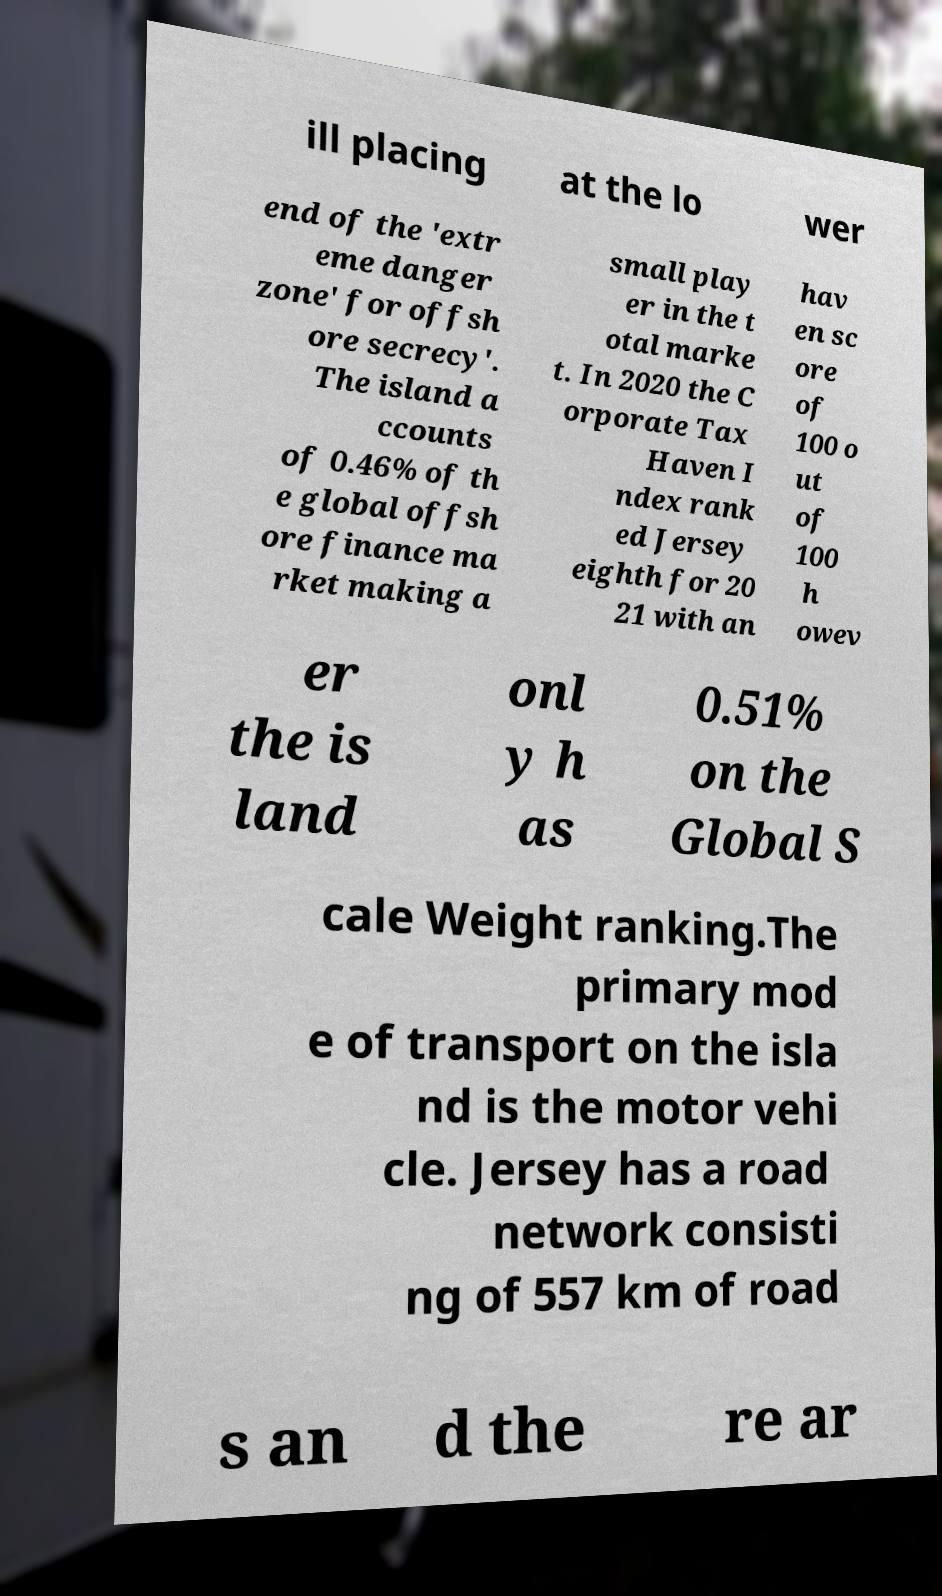Please read and relay the text visible in this image. What does it say? ill placing at the lo wer end of the 'extr eme danger zone' for offsh ore secrecy'. The island a ccounts of 0.46% of th e global offsh ore finance ma rket making a small play er in the t otal marke t. In 2020 the C orporate Tax Haven I ndex rank ed Jersey eighth for 20 21 with an hav en sc ore of 100 o ut of 100 h owev er the is land onl y h as 0.51% on the Global S cale Weight ranking.The primary mod e of transport on the isla nd is the motor vehi cle. Jersey has a road network consisti ng of 557 km of road s an d the re ar 